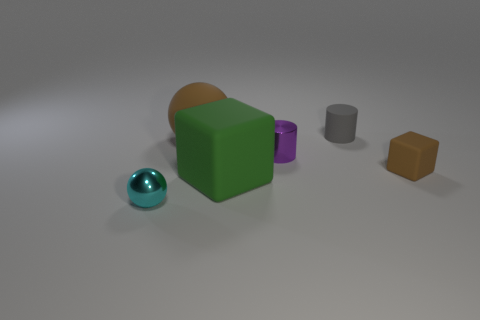The small matte object to the right of the cylinder that is behind the metallic object behind the cyan ball is what color? brown 